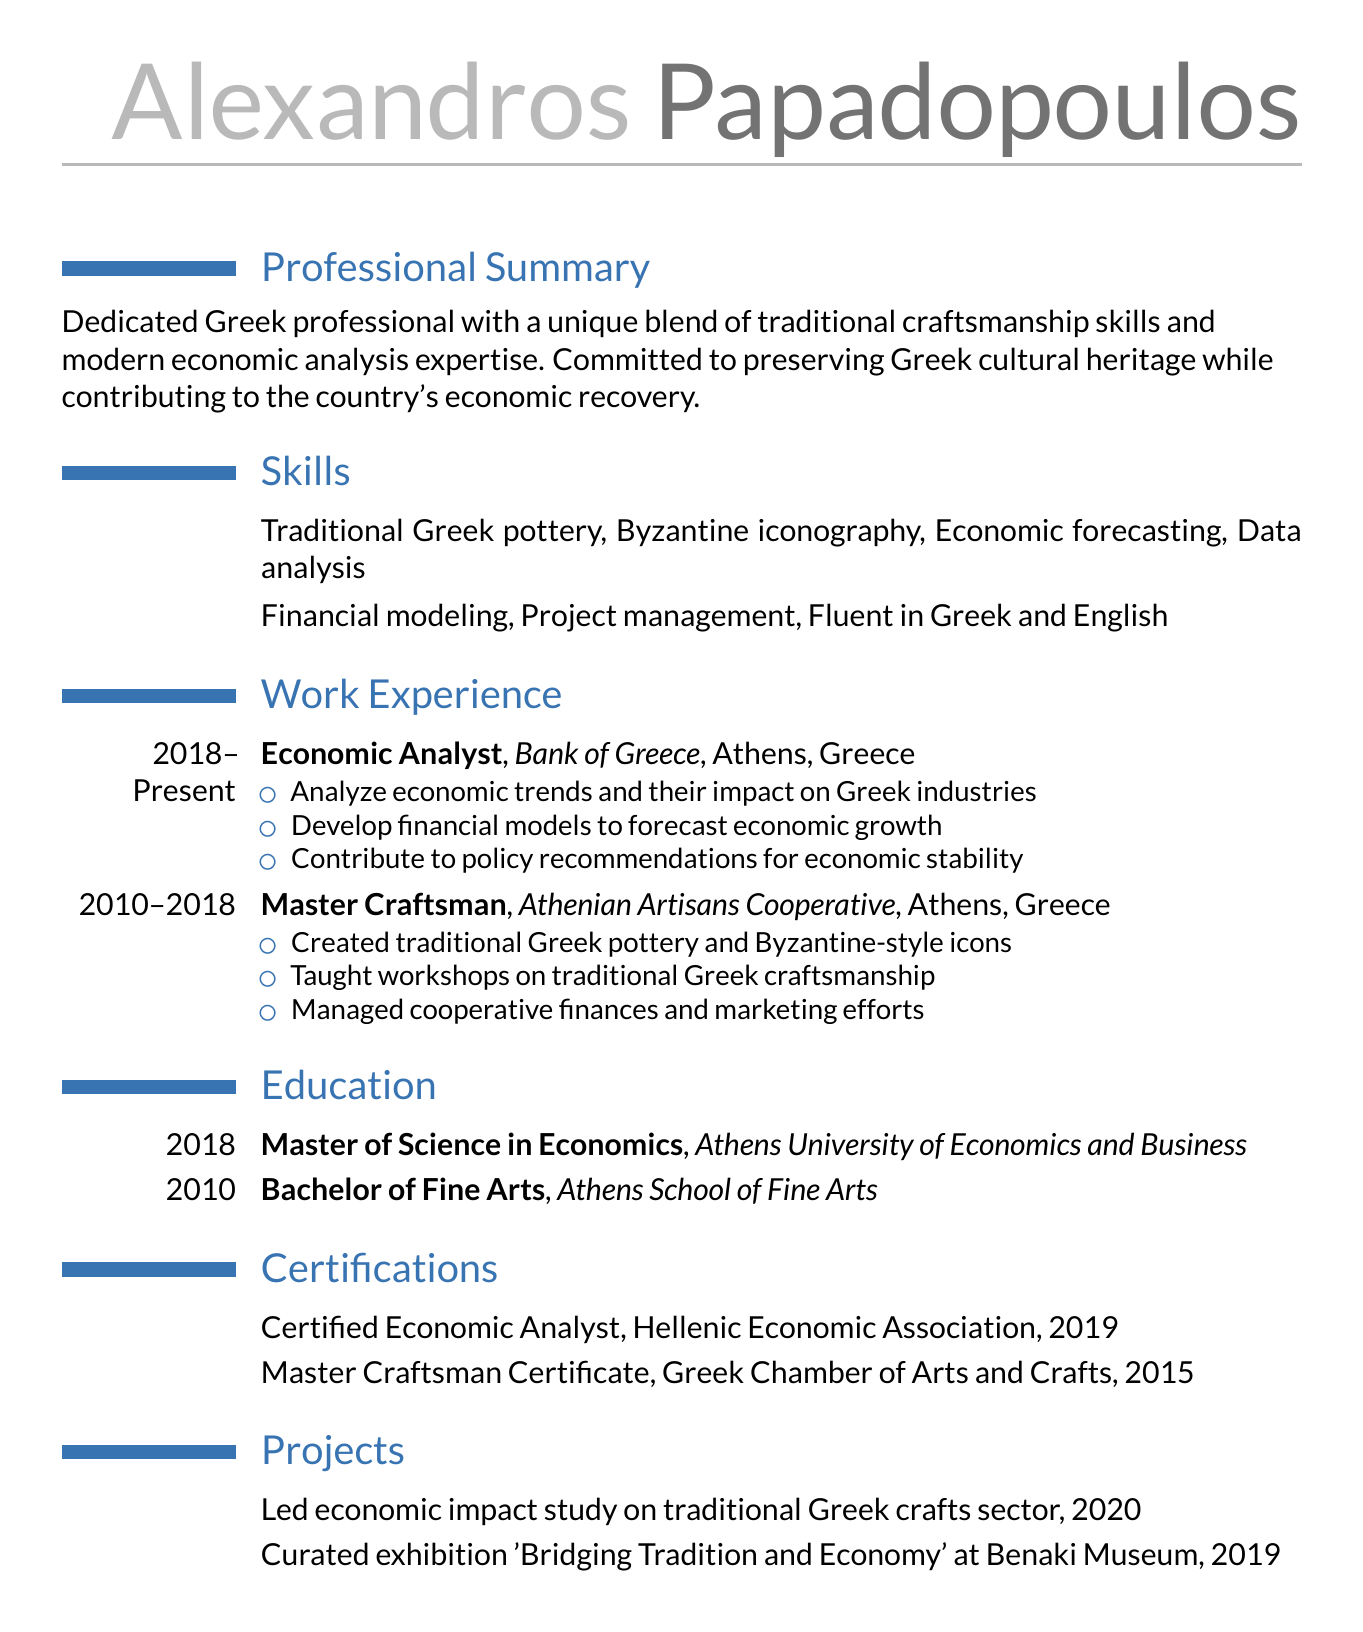What is the name of the individual? The name is listed at the top of the document under personal details.
Answer: Alexandros Papadopoulos What is the primary responsibility of the Economic Analyst? The responsibilities include analyzing economic trends and their impact on Greek industries.
Answer: Analyze economic trends In which year did Alexandros obtain their Master's degree? The education section lists the year each degree was obtained.
Answer: 2018 What is one of the skills listed in the resume? The skills section enumerates various skills relevant to the individual's profession.
Answer: Economic forecasting What organization did Alexandros work for as a Master Craftsman? The work experience section specifies the company where the individual performed various responsibilities.
Answer: Athenian Artisans Cooperative Which certification was obtained in 2019? The certifications section provides the names and years of certifications received.
Answer: Certified Economic Analyst What exhibition did Alexandros curate in 2019? The projects section lists notable projects that the individual undertook, including exhibitions.
Answer: Bridging Tradition and Economy How long did Alexandros work in the role of Master Craftsman? The work experience section provides the duration of each role listed.
Answer: 8 years What language is Alexandros fluent in besides Greek? The skills section indicates the languages in which the individual is proficient.
Answer: English 